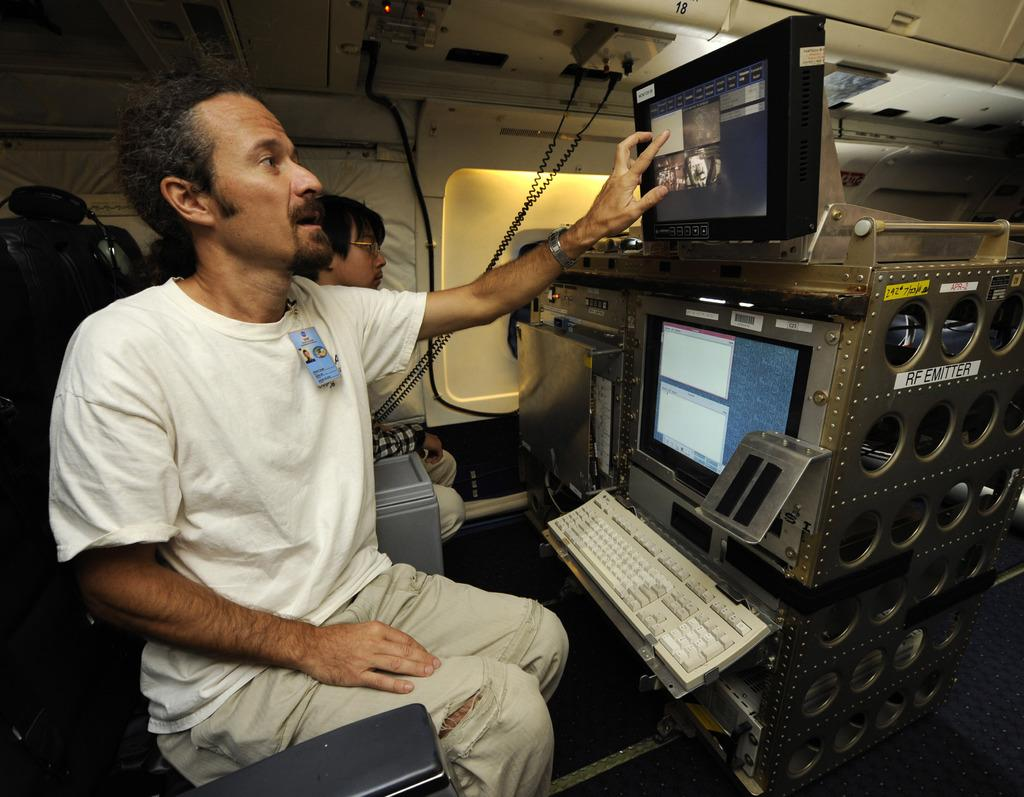<image>
Summarize the visual content of the image. A man is touching a screen at a computer station that says RF Emitter. 